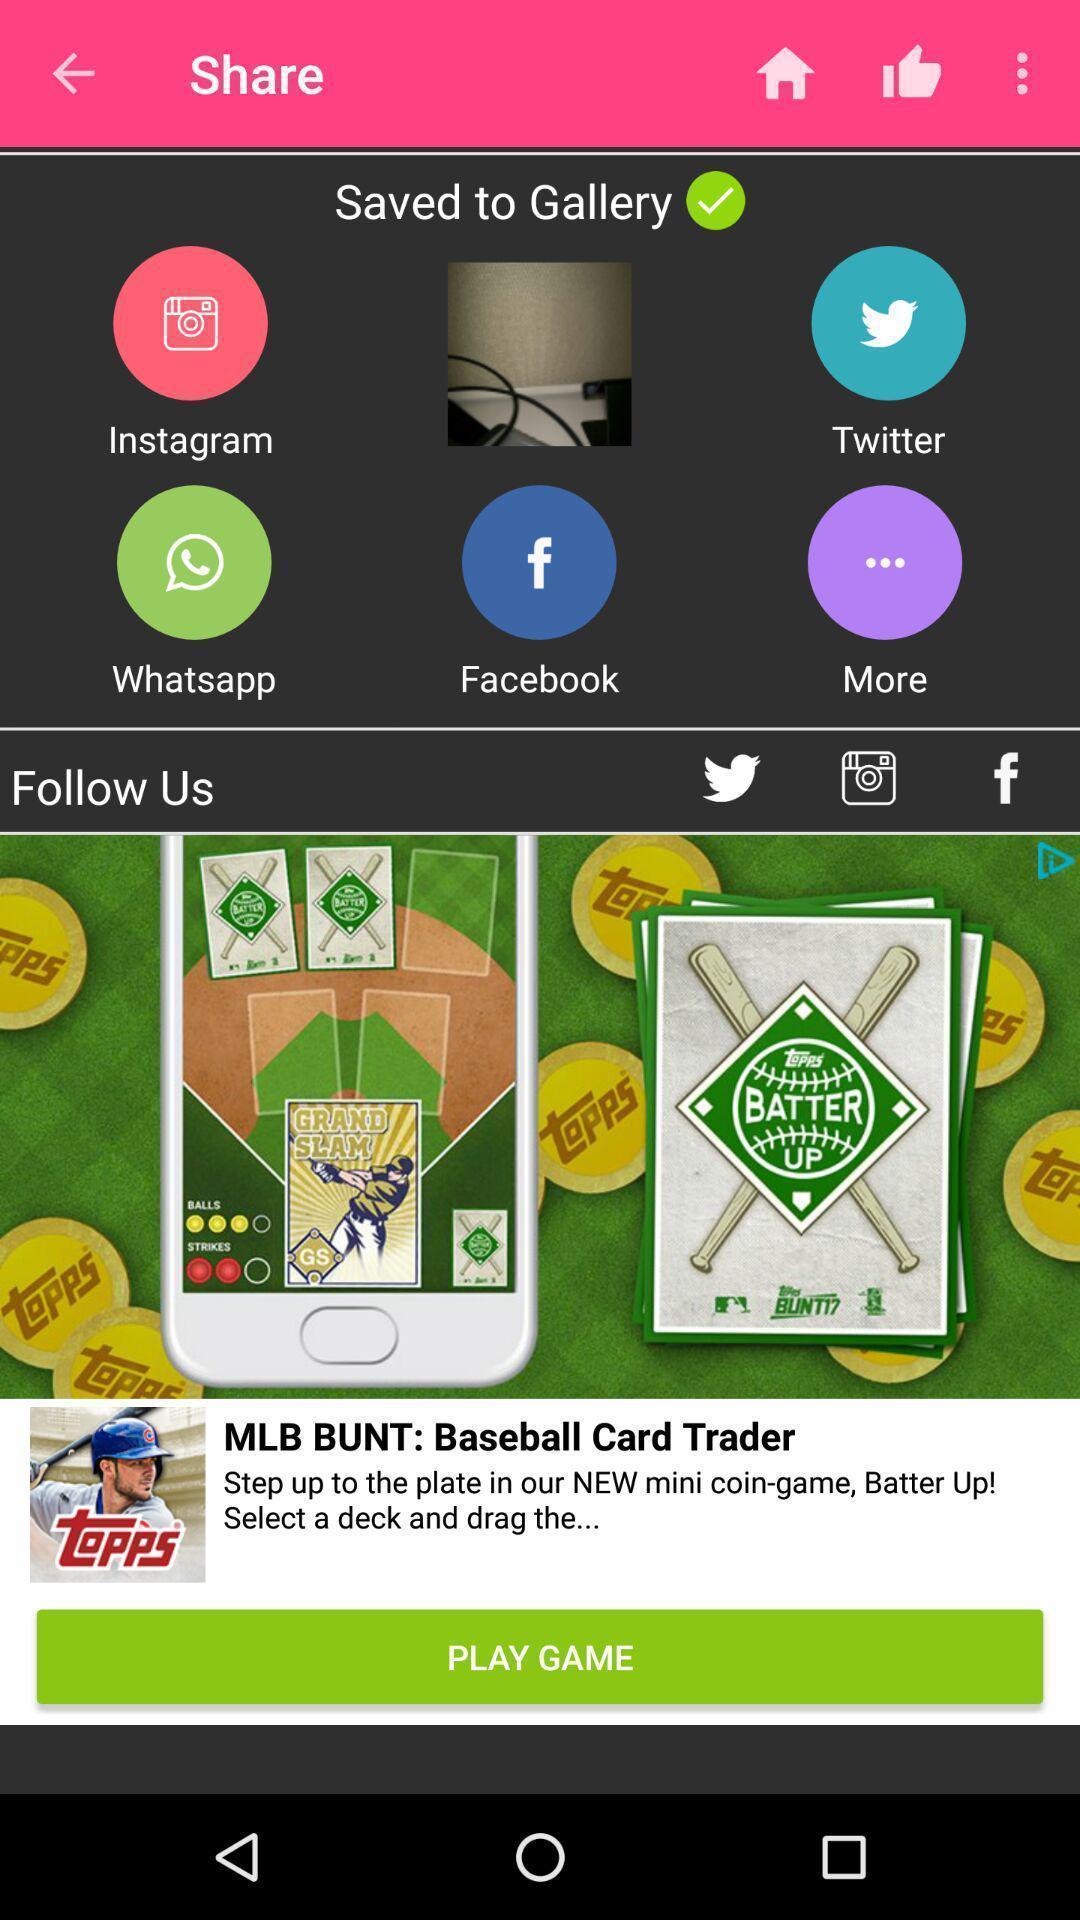What is the overall content of this screenshot? Screen displaying multiple social application icons and names. 